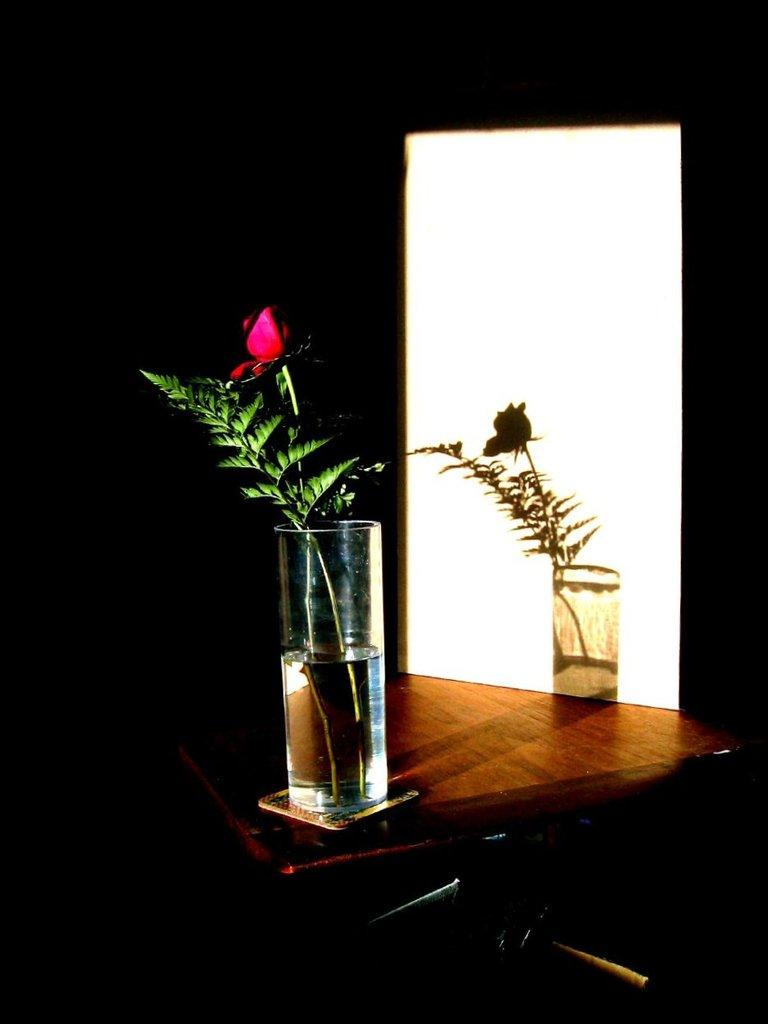What object is present in the image that typically holds flowers? There is a flower vase in the image. Where is the flower vase located? The flower vase is placed on a wooden table. What color or material can be seen at the bottom of the image? There is silver color visible at the bottom of the image. What is inside the flower vase? There is a flower in the flower vase. What type of company is the stranger looking for in the image? There is no stranger or company present in the image; it only features a flower vase with a flower on a wooden table. 